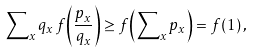Convert formula to latex. <formula><loc_0><loc_0><loc_500><loc_500>\sum \nolimits _ { x } { q _ { x } { \, } { f } { \left ( \frac { p _ { x } } { q _ { x } } \right ) } } \geq { f } { \left ( \sum \nolimits _ { x } { p _ { x } } \right ) } = f ( 1 ) { \, } ,</formula> 